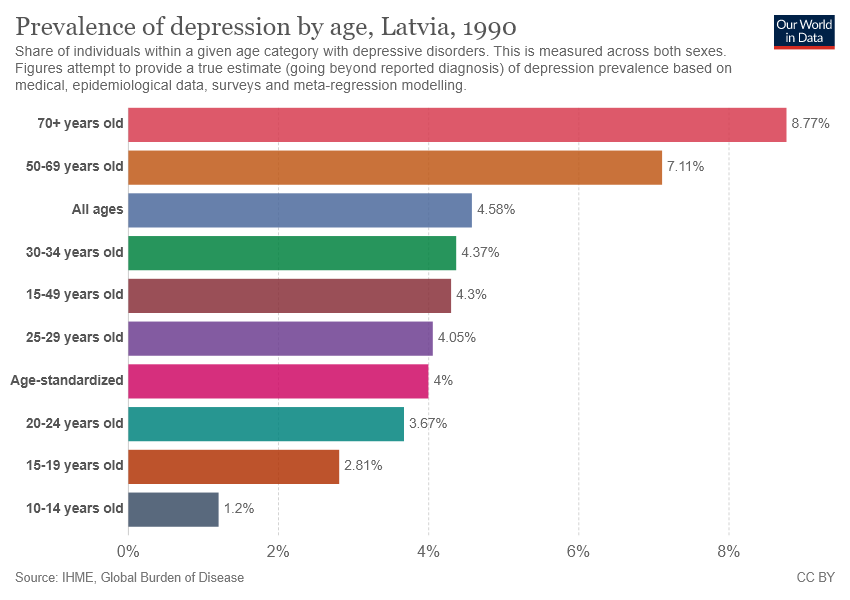Mention a couple of crucial points in this snapshot. The sum of the smallest two bars is not greater than the value of the 6th largest bar. The value of the first bar is 8.77 